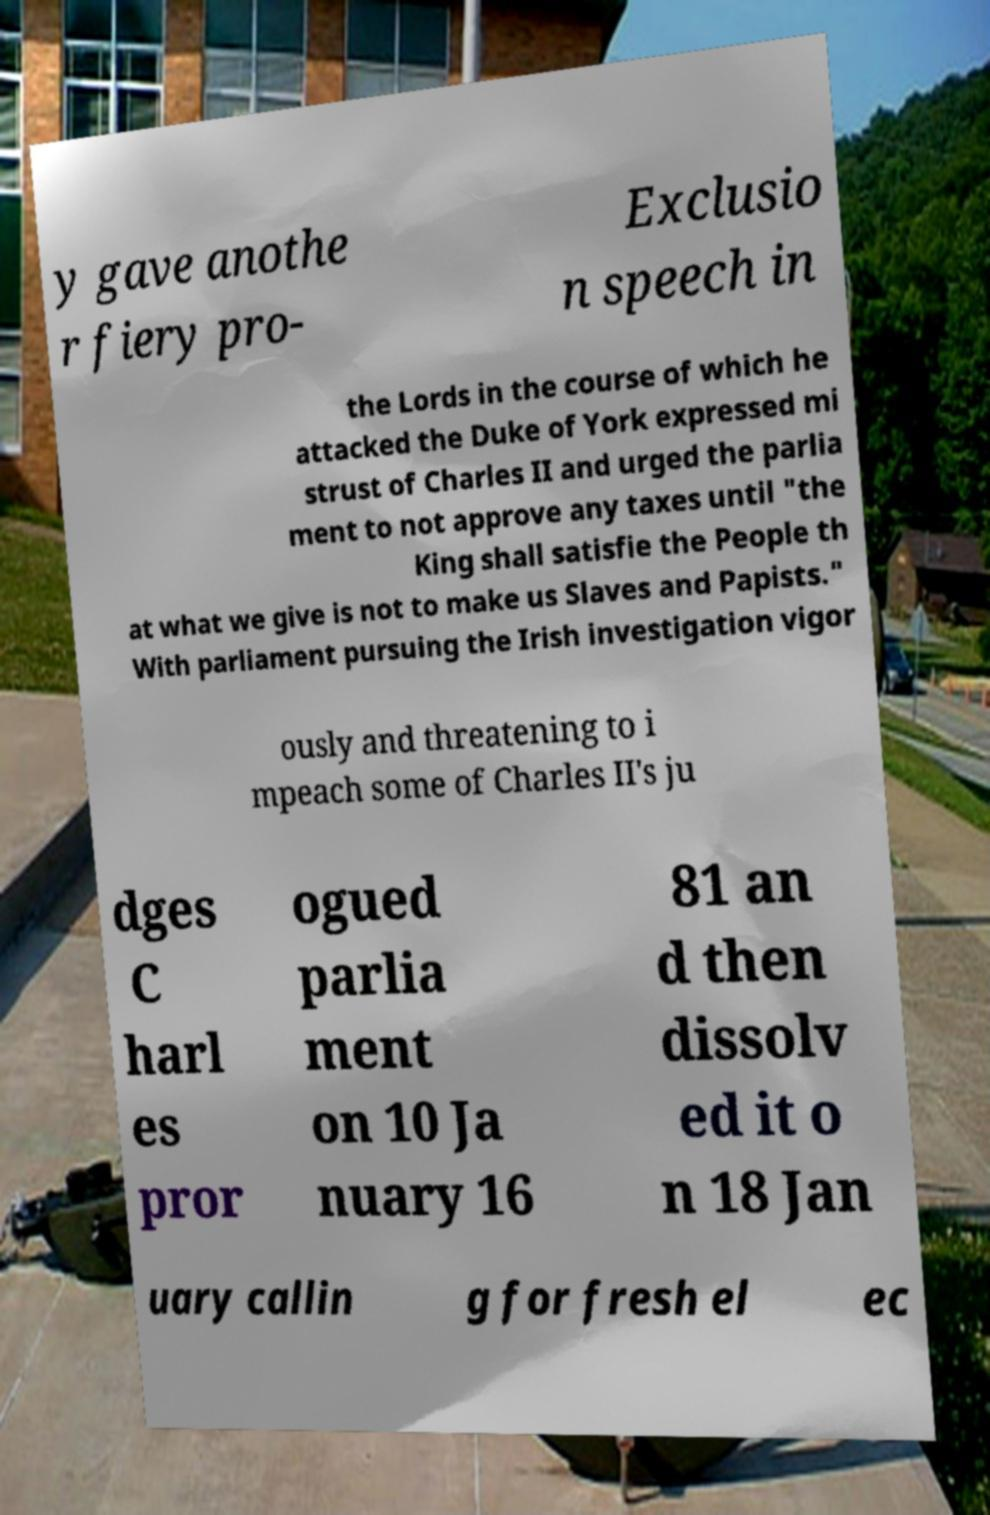Please read and relay the text visible in this image. What does it say? y gave anothe r fiery pro- Exclusio n speech in the Lords in the course of which he attacked the Duke of York expressed mi strust of Charles II and urged the parlia ment to not approve any taxes until "the King shall satisfie the People th at what we give is not to make us Slaves and Papists." With parliament pursuing the Irish investigation vigor ously and threatening to i mpeach some of Charles II's ju dges C harl es pror ogued parlia ment on 10 Ja nuary 16 81 an d then dissolv ed it o n 18 Jan uary callin g for fresh el ec 